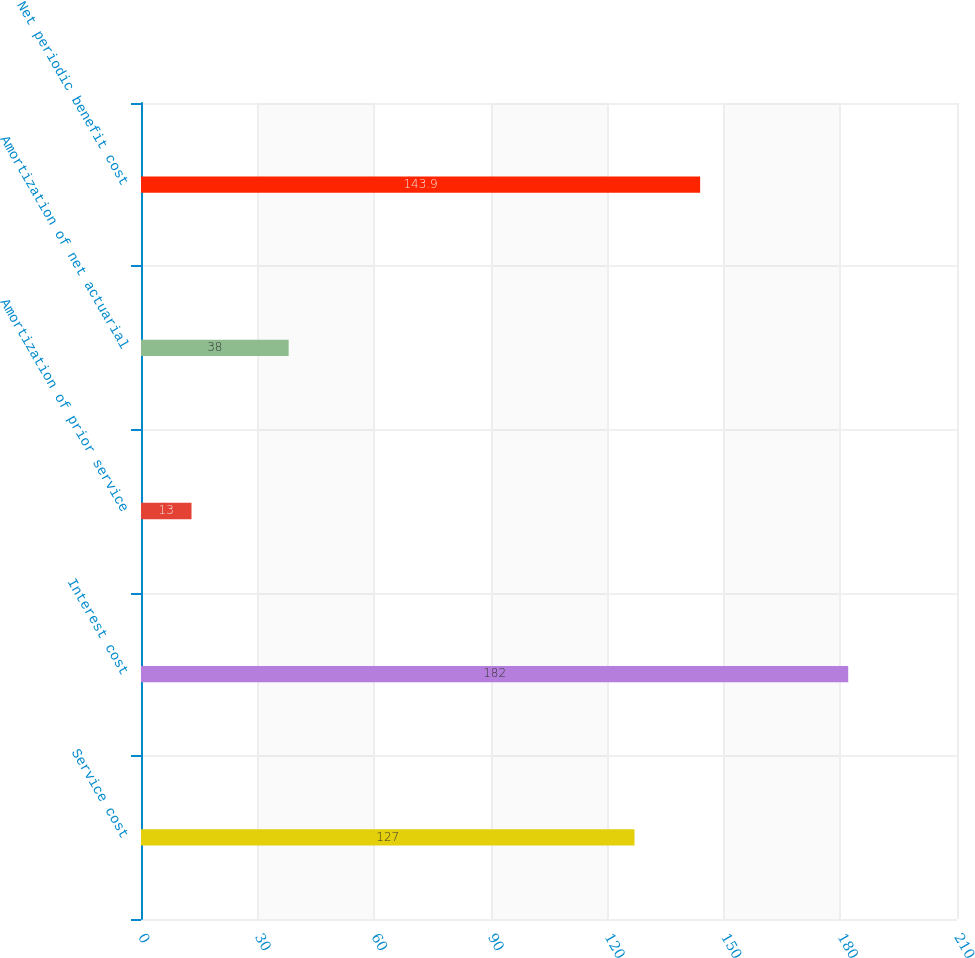Convert chart to OTSL. <chart><loc_0><loc_0><loc_500><loc_500><bar_chart><fcel>Service cost<fcel>Interest cost<fcel>Amortization of prior service<fcel>Amortization of net actuarial<fcel>Net periodic benefit cost<nl><fcel>127<fcel>182<fcel>13<fcel>38<fcel>143.9<nl></chart> 